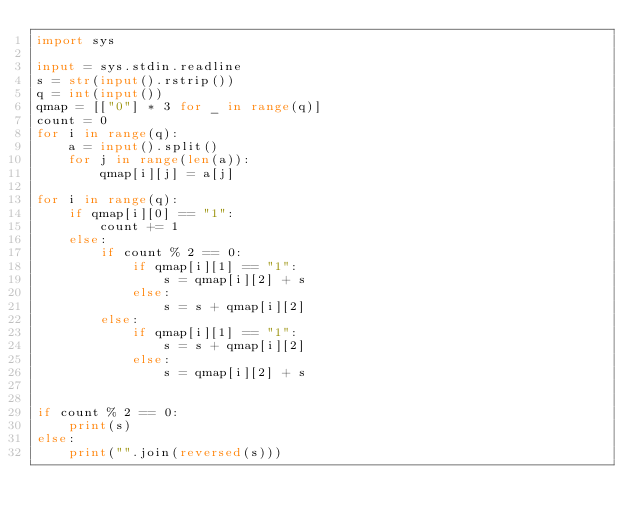Convert code to text. <code><loc_0><loc_0><loc_500><loc_500><_Python_>import sys

input = sys.stdin.readline
s = str(input().rstrip())
q = int(input())
qmap = [["0"] * 3 for _ in range(q)]
count = 0
for i in range(q):
    a = input().split()
    for j in range(len(a)):
        qmap[i][j] = a[j]

for i in range(q):
    if qmap[i][0] == "1":
        count += 1
    else:
        if count % 2 == 0:
            if qmap[i][1] == "1":
                s = qmap[i][2] + s
            else:
                s = s + qmap[i][2]
        else:
            if qmap[i][1] == "1":
                s = s + qmap[i][2]
            else:
                s = qmap[i][2] + s


if count % 2 == 0:
    print(s)
else:
    print("".join(reversed(s)))

</code> 